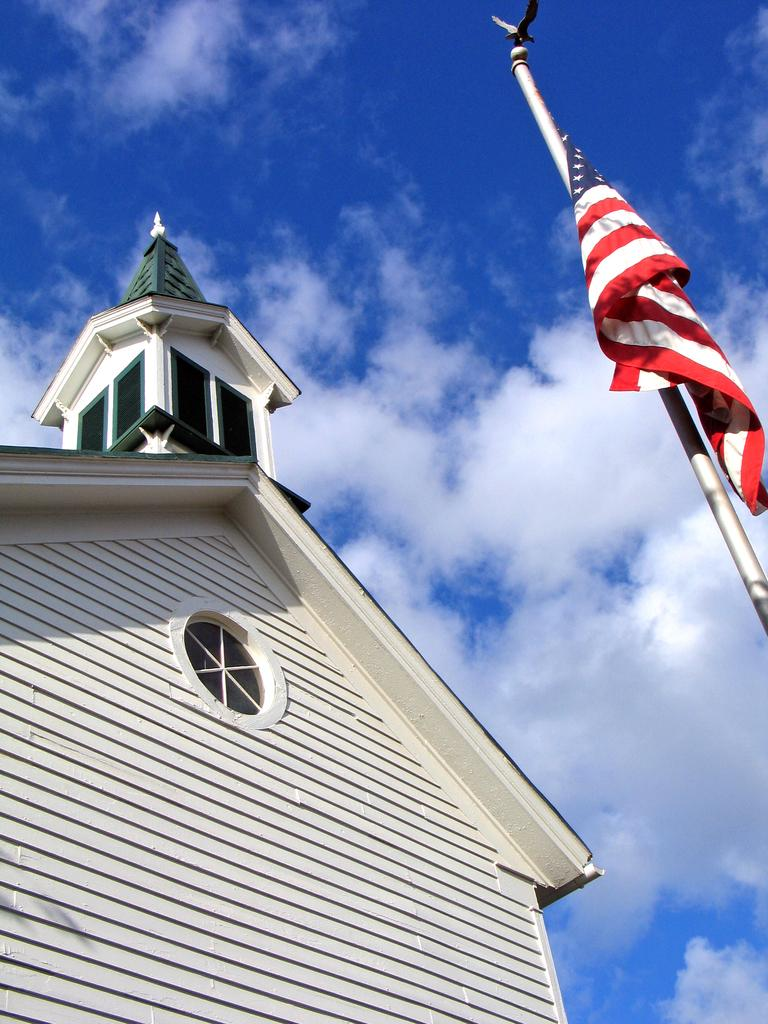What type of structure is present in the image? There is a building in the image. What else can be seen in the image besides the building? There is a pole and a flag in the image. What is visible in the background of the image? The sky is visible in the background of the image. What can be observed about the sky in the image? There are clouds in the sky. How many passengers are visible in the image? There are no passengers present in the image. What type of flock is flying in the sky in the image? There are no birds or flocks visible in the image; only clouds can be seen in the sky. 